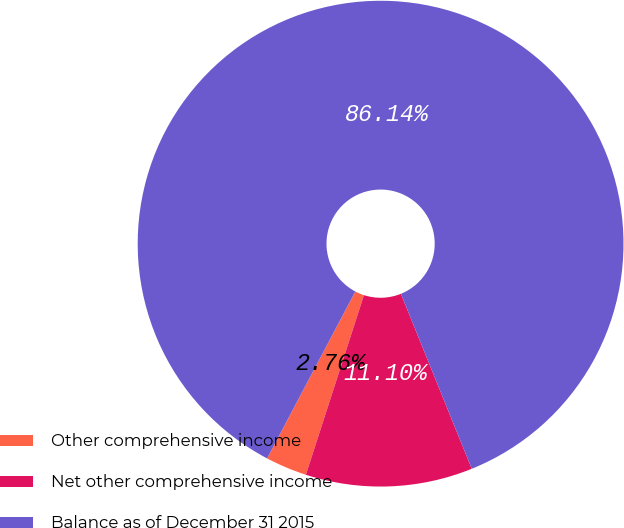Convert chart. <chart><loc_0><loc_0><loc_500><loc_500><pie_chart><fcel>Other comprehensive income<fcel>Net other comprehensive income<fcel>Balance as of December 31 2015<nl><fcel>2.76%<fcel>11.1%<fcel>86.14%<nl></chart> 